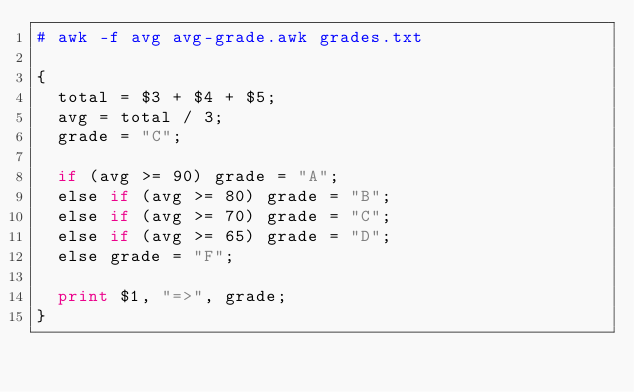<code> <loc_0><loc_0><loc_500><loc_500><_Awk_># awk -f avg avg-grade.awk grades.txt

{
  total = $3 + $4 + $5;
  avg = total / 3;
  grade = "C";

  if (avg >= 90) grade = "A";
  else if (avg >= 80) grade = "B";
  else if (avg >= 70) grade = "C";
  else if (avg >= 65) grade = "D";
  else grade = "F";

  print $1, "=>", grade;
}
</code> 